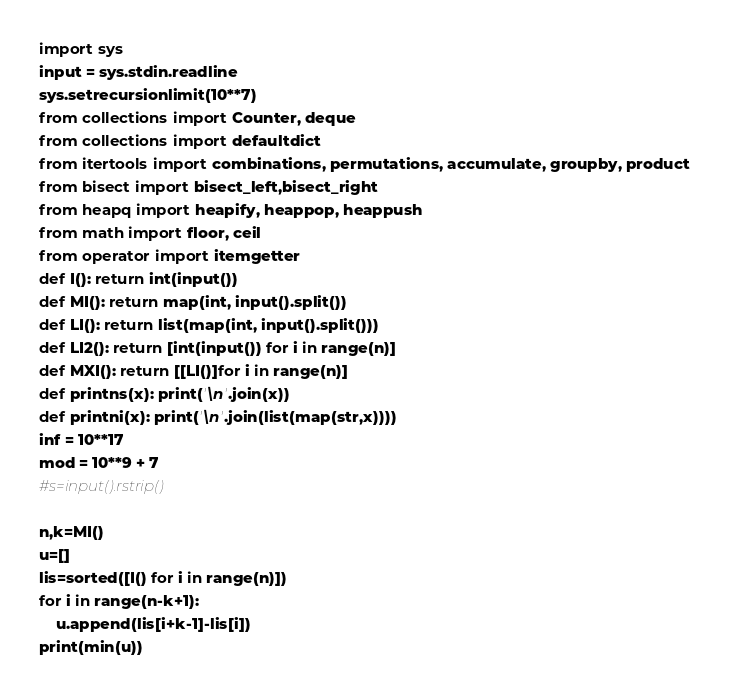<code> <loc_0><loc_0><loc_500><loc_500><_Python_>import sys
input = sys.stdin.readline
sys.setrecursionlimit(10**7)
from collections import Counter, deque
from collections import defaultdict
from itertools import combinations, permutations, accumulate, groupby, product
from bisect import bisect_left,bisect_right
from heapq import heapify, heappop, heappush
from math import floor, ceil
from operator import itemgetter
def I(): return int(input())
def MI(): return map(int, input().split())
def LI(): return list(map(int, input().split()))
def LI2(): return [int(input()) for i in range(n)]
def MXI(): return [[LI()]for i in range(n)]
def printns(x): print('\n'.join(x))
def printni(x): print('\n'.join(list(map(str,x))))
inf = 10**17
mod = 10**9 + 7
#s=input().rstrip()

n,k=MI()
u=[]
lis=sorted([I() for i in range(n)])
for i in range(n-k+1):
    u.append(lis[i+k-1]-lis[i])
print(min(u))</code> 